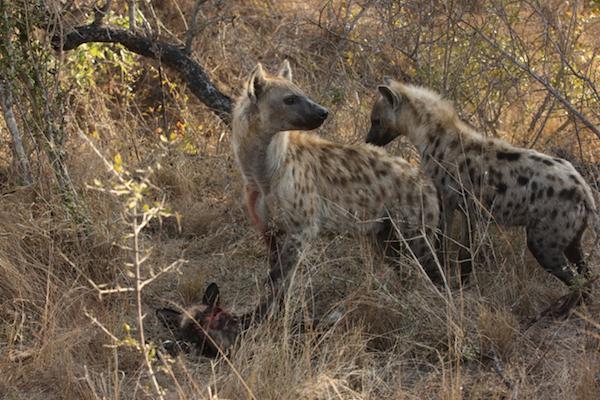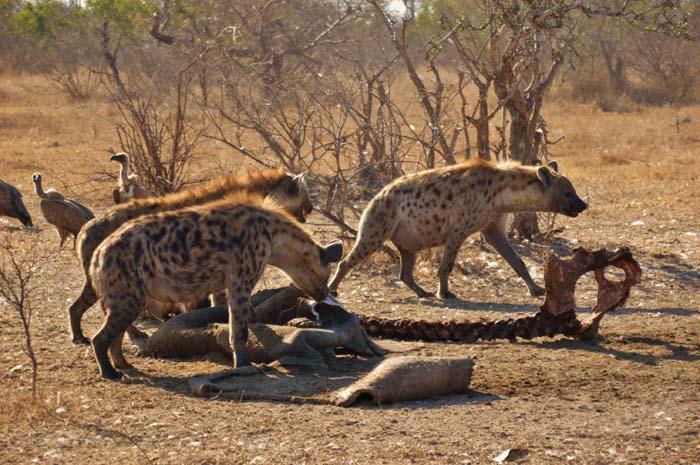The first image is the image on the left, the second image is the image on the right. Analyze the images presented: Is the assertion "At least one animal is carrying a piece of its prey in its mouth." valid? Answer yes or no. No. The first image is the image on the left, the second image is the image on the right. Assess this claim about the two images: "A hyena is carrying off the head of its prey in one of the images.". Correct or not? Answer yes or no. No. 